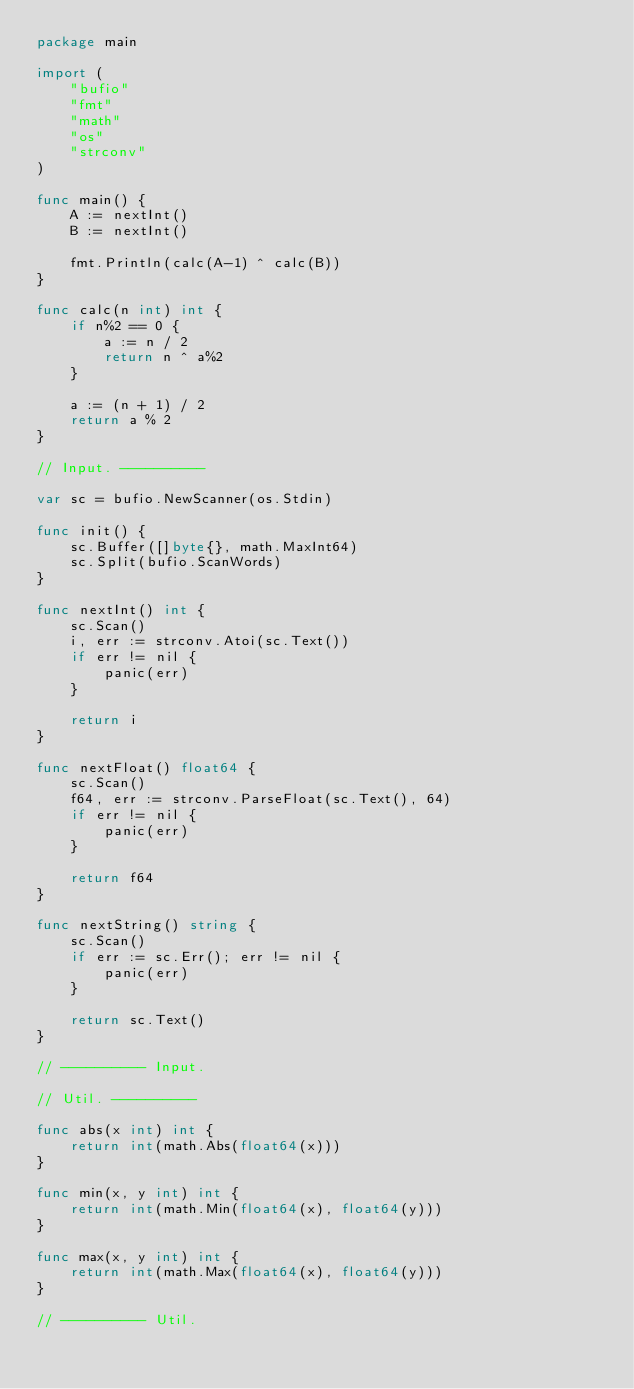Convert code to text. <code><loc_0><loc_0><loc_500><loc_500><_Go_>package main

import (
	"bufio"
	"fmt"
	"math"
	"os"
	"strconv"
)

func main() {
	A := nextInt()
	B := nextInt()

	fmt.Println(calc(A-1) ^ calc(B))
}

func calc(n int) int {
	if n%2 == 0 {
		a := n / 2
		return n ^ a%2
	}

	a := (n + 1) / 2
	return a % 2
}

// Input. ----------

var sc = bufio.NewScanner(os.Stdin)

func init() {
	sc.Buffer([]byte{}, math.MaxInt64)
	sc.Split(bufio.ScanWords)
}

func nextInt() int {
	sc.Scan()
	i, err := strconv.Atoi(sc.Text())
	if err != nil {
		panic(err)
	}

	return i
}

func nextFloat() float64 {
	sc.Scan()
	f64, err := strconv.ParseFloat(sc.Text(), 64)
	if err != nil {
		panic(err)
	}

	return f64
}

func nextString() string {
	sc.Scan()
	if err := sc.Err(); err != nil {
		panic(err)
	}

	return sc.Text()
}

// ---------- Input.

// Util. ----------

func abs(x int) int {
	return int(math.Abs(float64(x)))
}

func min(x, y int) int {
	return int(math.Min(float64(x), float64(y)))
}

func max(x, y int) int {
	return int(math.Max(float64(x), float64(y)))
}

// ---------- Util.
</code> 